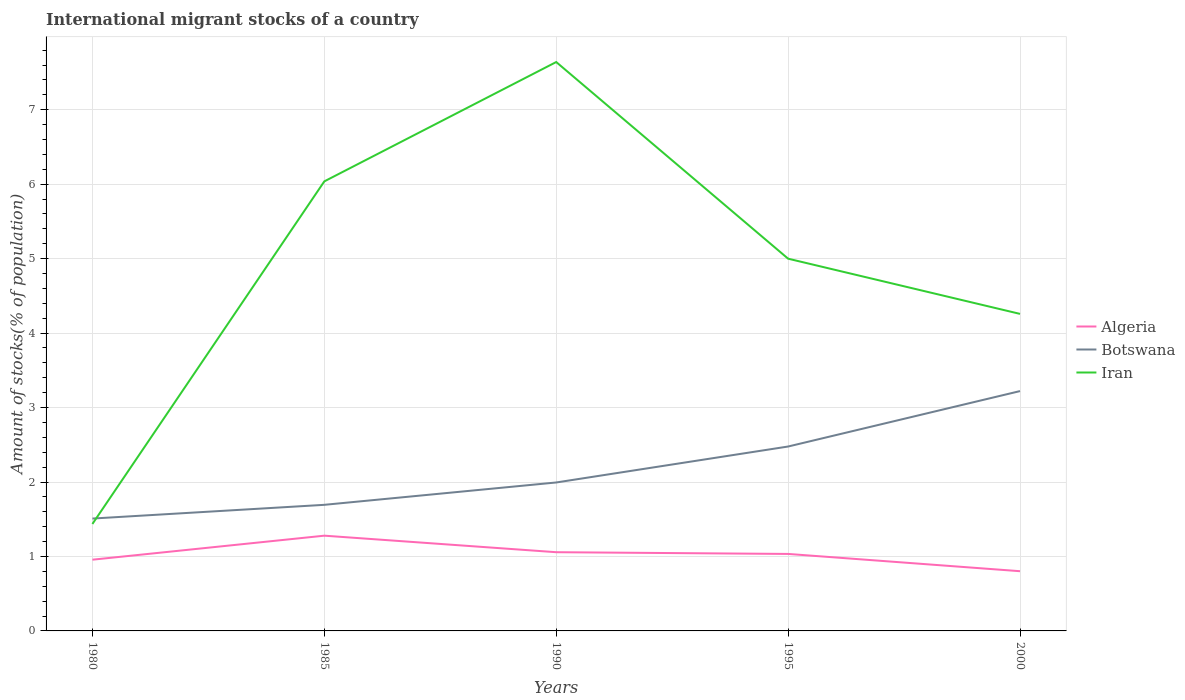How many different coloured lines are there?
Provide a short and direct response. 3. Does the line corresponding to Algeria intersect with the line corresponding to Botswana?
Keep it short and to the point. No. Is the number of lines equal to the number of legend labels?
Provide a succinct answer. Yes. Across all years, what is the maximum amount of stocks in in Iran?
Provide a short and direct response. 1.44. What is the total amount of stocks in in Botswana in the graph?
Your answer should be very brief. -0.97. What is the difference between the highest and the second highest amount of stocks in in Algeria?
Your answer should be very brief. 0.48. What is the difference between the highest and the lowest amount of stocks in in Botswana?
Your response must be concise. 2. Is the amount of stocks in in Iran strictly greater than the amount of stocks in in Botswana over the years?
Your answer should be very brief. No. How many lines are there?
Give a very brief answer. 3. What is the difference between two consecutive major ticks on the Y-axis?
Offer a terse response. 1. Does the graph contain any zero values?
Ensure brevity in your answer.  No. How are the legend labels stacked?
Your answer should be very brief. Vertical. What is the title of the graph?
Your answer should be compact. International migrant stocks of a country. What is the label or title of the X-axis?
Keep it short and to the point. Years. What is the label or title of the Y-axis?
Your answer should be very brief. Amount of stocks(% of population). What is the Amount of stocks(% of population) of Algeria in 1980?
Offer a very short reply. 0.96. What is the Amount of stocks(% of population) of Botswana in 1980?
Give a very brief answer. 1.51. What is the Amount of stocks(% of population) of Iran in 1980?
Offer a terse response. 1.44. What is the Amount of stocks(% of population) of Algeria in 1985?
Provide a succinct answer. 1.28. What is the Amount of stocks(% of population) in Botswana in 1985?
Ensure brevity in your answer.  1.69. What is the Amount of stocks(% of population) in Iran in 1985?
Ensure brevity in your answer.  6.04. What is the Amount of stocks(% of population) of Algeria in 1990?
Offer a very short reply. 1.06. What is the Amount of stocks(% of population) of Botswana in 1990?
Your response must be concise. 1.99. What is the Amount of stocks(% of population) of Iran in 1990?
Your response must be concise. 7.64. What is the Amount of stocks(% of population) of Algeria in 1995?
Keep it short and to the point. 1.03. What is the Amount of stocks(% of population) in Botswana in 1995?
Keep it short and to the point. 2.48. What is the Amount of stocks(% of population) in Iran in 1995?
Offer a very short reply. 5. What is the Amount of stocks(% of population) of Algeria in 2000?
Your answer should be very brief. 0.8. What is the Amount of stocks(% of population) in Botswana in 2000?
Give a very brief answer. 3.22. What is the Amount of stocks(% of population) in Iran in 2000?
Ensure brevity in your answer.  4.26. Across all years, what is the maximum Amount of stocks(% of population) in Algeria?
Your answer should be very brief. 1.28. Across all years, what is the maximum Amount of stocks(% of population) in Botswana?
Your answer should be compact. 3.22. Across all years, what is the maximum Amount of stocks(% of population) in Iran?
Keep it short and to the point. 7.64. Across all years, what is the minimum Amount of stocks(% of population) of Algeria?
Make the answer very short. 0.8. Across all years, what is the minimum Amount of stocks(% of population) of Botswana?
Provide a short and direct response. 1.51. Across all years, what is the minimum Amount of stocks(% of population) in Iran?
Provide a succinct answer. 1.44. What is the total Amount of stocks(% of population) of Algeria in the graph?
Offer a terse response. 5.13. What is the total Amount of stocks(% of population) of Botswana in the graph?
Your answer should be compact. 10.89. What is the total Amount of stocks(% of population) of Iran in the graph?
Keep it short and to the point. 24.37. What is the difference between the Amount of stocks(% of population) in Algeria in 1980 and that in 1985?
Give a very brief answer. -0.32. What is the difference between the Amount of stocks(% of population) of Botswana in 1980 and that in 1985?
Your answer should be compact. -0.18. What is the difference between the Amount of stocks(% of population) in Iran in 1980 and that in 1985?
Offer a very short reply. -4.6. What is the difference between the Amount of stocks(% of population) of Algeria in 1980 and that in 1990?
Keep it short and to the point. -0.1. What is the difference between the Amount of stocks(% of population) in Botswana in 1980 and that in 1990?
Keep it short and to the point. -0.48. What is the difference between the Amount of stocks(% of population) in Iran in 1980 and that in 1990?
Offer a very short reply. -6.2. What is the difference between the Amount of stocks(% of population) in Algeria in 1980 and that in 1995?
Offer a very short reply. -0.08. What is the difference between the Amount of stocks(% of population) of Botswana in 1980 and that in 1995?
Provide a short and direct response. -0.97. What is the difference between the Amount of stocks(% of population) of Iran in 1980 and that in 1995?
Make the answer very short. -3.56. What is the difference between the Amount of stocks(% of population) of Algeria in 1980 and that in 2000?
Your answer should be very brief. 0.15. What is the difference between the Amount of stocks(% of population) of Botswana in 1980 and that in 2000?
Provide a short and direct response. -1.71. What is the difference between the Amount of stocks(% of population) in Iran in 1980 and that in 2000?
Make the answer very short. -2.82. What is the difference between the Amount of stocks(% of population) in Algeria in 1985 and that in 1990?
Provide a succinct answer. 0.22. What is the difference between the Amount of stocks(% of population) of Botswana in 1985 and that in 1990?
Keep it short and to the point. -0.3. What is the difference between the Amount of stocks(% of population) of Iran in 1985 and that in 1990?
Ensure brevity in your answer.  -1.6. What is the difference between the Amount of stocks(% of population) in Algeria in 1985 and that in 1995?
Provide a short and direct response. 0.25. What is the difference between the Amount of stocks(% of population) of Botswana in 1985 and that in 1995?
Your answer should be very brief. -0.78. What is the difference between the Amount of stocks(% of population) of Iran in 1985 and that in 1995?
Provide a succinct answer. 1.04. What is the difference between the Amount of stocks(% of population) of Algeria in 1985 and that in 2000?
Offer a very short reply. 0.48. What is the difference between the Amount of stocks(% of population) in Botswana in 1985 and that in 2000?
Offer a very short reply. -1.53. What is the difference between the Amount of stocks(% of population) of Iran in 1985 and that in 2000?
Offer a very short reply. 1.78. What is the difference between the Amount of stocks(% of population) of Algeria in 1990 and that in 1995?
Your response must be concise. 0.02. What is the difference between the Amount of stocks(% of population) in Botswana in 1990 and that in 1995?
Offer a terse response. -0.48. What is the difference between the Amount of stocks(% of population) of Iran in 1990 and that in 1995?
Provide a succinct answer. 2.64. What is the difference between the Amount of stocks(% of population) in Algeria in 1990 and that in 2000?
Give a very brief answer. 0.26. What is the difference between the Amount of stocks(% of population) of Botswana in 1990 and that in 2000?
Ensure brevity in your answer.  -1.23. What is the difference between the Amount of stocks(% of population) of Iran in 1990 and that in 2000?
Your response must be concise. 3.38. What is the difference between the Amount of stocks(% of population) in Algeria in 1995 and that in 2000?
Offer a very short reply. 0.23. What is the difference between the Amount of stocks(% of population) of Botswana in 1995 and that in 2000?
Ensure brevity in your answer.  -0.74. What is the difference between the Amount of stocks(% of population) of Iran in 1995 and that in 2000?
Provide a succinct answer. 0.74. What is the difference between the Amount of stocks(% of population) of Algeria in 1980 and the Amount of stocks(% of population) of Botswana in 1985?
Make the answer very short. -0.74. What is the difference between the Amount of stocks(% of population) of Algeria in 1980 and the Amount of stocks(% of population) of Iran in 1985?
Make the answer very short. -5.08. What is the difference between the Amount of stocks(% of population) in Botswana in 1980 and the Amount of stocks(% of population) in Iran in 1985?
Make the answer very short. -4.53. What is the difference between the Amount of stocks(% of population) in Algeria in 1980 and the Amount of stocks(% of population) in Botswana in 1990?
Give a very brief answer. -1.04. What is the difference between the Amount of stocks(% of population) of Algeria in 1980 and the Amount of stocks(% of population) of Iran in 1990?
Your answer should be compact. -6.68. What is the difference between the Amount of stocks(% of population) in Botswana in 1980 and the Amount of stocks(% of population) in Iran in 1990?
Your answer should be very brief. -6.13. What is the difference between the Amount of stocks(% of population) of Algeria in 1980 and the Amount of stocks(% of population) of Botswana in 1995?
Your response must be concise. -1.52. What is the difference between the Amount of stocks(% of population) in Algeria in 1980 and the Amount of stocks(% of population) in Iran in 1995?
Keep it short and to the point. -4.04. What is the difference between the Amount of stocks(% of population) in Botswana in 1980 and the Amount of stocks(% of population) in Iran in 1995?
Keep it short and to the point. -3.49. What is the difference between the Amount of stocks(% of population) in Algeria in 1980 and the Amount of stocks(% of population) in Botswana in 2000?
Offer a very short reply. -2.26. What is the difference between the Amount of stocks(% of population) in Algeria in 1980 and the Amount of stocks(% of population) in Iran in 2000?
Your answer should be very brief. -3.3. What is the difference between the Amount of stocks(% of population) in Botswana in 1980 and the Amount of stocks(% of population) in Iran in 2000?
Your answer should be compact. -2.75. What is the difference between the Amount of stocks(% of population) of Algeria in 1985 and the Amount of stocks(% of population) of Botswana in 1990?
Make the answer very short. -0.71. What is the difference between the Amount of stocks(% of population) of Algeria in 1985 and the Amount of stocks(% of population) of Iran in 1990?
Keep it short and to the point. -6.36. What is the difference between the Amount of stocks(% of population) of Botswana in 1985 and the Amount of stocks(% of population) of Iran in 1990?
Give a very brief answer. -5.95. What is the difference between the Amount of stocks(% of population) of Algeria in 1985 and the Amount of stocks(% of population) of Botswana in 1995?
Make the answer very short. -1.2. What is the difference between the Amount of stocks(% of population) of Algeria in 1985 and the Amount of stocks(% of population) of Iran in 1995?
Your answer should be compact. -3.72. What is the difference between the Amount of stocks(% of population) of Botswana in 1985 and the Amount of stocks(% of population) of Iran in 1995?
Make the answer very short. -3.31. What is the difference between the Amount of stocks(% of population) of Algeria in 1985 and the Amount of stocks(% of population) of Botswana in 2000?
Provide a short and direct response. -1.94. What is the difference between the Amount of stocks(% of population) in Algeria in 1985 and the Amount of stocks(% of population) in Iran in 2000?
Keep it short and to the point. -2.98. What is the difference between the Amount of stocks(% of population) in Botswana in 1985 and the Amount of stocks(% of population) in Iran in 2000?
Your answer should be compact. -2.56. What is the difference between the Amount of stocks(% of population) of Algeria in 1990 and the Amount of stocks(% of population) of Botswana in 1995?
Ensure brevity in your answer.  -1.42. What is the difference between the Amount of stocks(% of population) of Algeria in 1990 and the Amount of stocks(% of population) of Iran in 1995?
Give a very brief answer. -3.94. What is the difference between the Amount of stocks(% of population) in Botswana in 1990 and the Amount of stocks(% of population) in Iran in 1995?
Your answer should be compact. -3.01. What is the difference between the Amount of stocks(% of population) of Algeria in 1990 and the Amount of stocks(% of population) of Botswana in 2000?
Provide a short and direct response. -2.16. What is the difference between the Amount of stocks(% of population) in Algeria in 1990 and the Amount of stocks(% of population) in Iran in 2000?
Give a very brief answer. -3.2. What is the difference between the Amount of stocks(% of population) in Botswana in 1990 and the Amount of stocks(% of population) in Iran in 2000?
Provide a succinct answer. -2.26. What is the difference between the Amount of stocks(% of population) of Algeria in 1995 and the Amount of stocks(% of population) of Botswana in 2000?
Ensure brevity in your answer.  -2.19. What is the difference between the Amount of stocks(% of population) in Algeria in 1995 and the Amount of stocks(% of population) in Iran in 2000?
Keep it short and to the point. -3.22. What is the difference between the Amount of stocks(% of population) in Botswana in 1995 and the Amount of stocks(% of population) in Iran in 2000?
Provide a succinct answer. -1.78. What is the average Amount of stocks(% of population) of Algeria per year?
Ensure brevity in your answer.  1.03. What is the average Amount of stocks(% of population) in Botswana per year?
Keep it short and to the point. 2.18. What is the average Amount of stocks(% of population) of Iran per year?
Your answer should be very brief. 4.87. In the year 1980, what is the difference between the Amount of stocks(% of population) in Algeria and Amount of stocks(% of population) in Botswana?
Ensure brevity in your answer.  -0.55. In the year 1980, what is the difference between the Amount of stocks(% of population) of Algeria and Amount of stocks(% of population) of Iran?
Provide a succinct answer. -0.48. In the year 1980, what is the difference between the Amount of stocks(% of population) in Botswana and Amount of stocks(% of population) in Iran?
Ensure brevity in your answer.  0.07. In the year 1985, what is the difference between the Amount of stocks(% of population) of Algeria and Amount of stocks(% of population) of Botswana?
Your answer should be compact. -0.41. In the year 1985, what is the difference between the Amount of stocks(% of population) in Algeria and Amount of stocks(% of population) in Iran?
Your answer should be compact. -4.76. In the year 1985, what is the difference between the Amount of stocks(% of population) in Botswana and Amount of stocks(% of population) in Iran?
Provide a short and direct response. -4.34. In the year 1990, what is the difference between the Amount of stocks(% of population) in Algeria and Amount of stocks(% of population) in Botswana?
Provide a short and direct response. -0.94. In the year 1990, what is the difference between the Amount of stocks(% of population) of Algeria and Amount of stocks(% of population) of Iran?
Make the answer very short. -6.58. In the year 1990, what is the difference between the Amount of stocks(% of population) of Botswana and Amount of stocks(% of population) of Iran?
Ensure brevity in your answer.  -5.65. In the year 1995, what is the difference between the Amount of stocks(% of population) of Algeria and Amount of stocks(% of population) of Botswana?
Provide a succinct answer. -1.44. In the year 1995, what is the difference between the Amount of stocks(% of population) of Algeria and Amount of stocks(% of population) of Iran?
Your response must be concise. -3.97. In the year 1995, what is the difference between the Amount of stocks(% of population) in Botswana and Amount of stocks(% of population) in Iran?
Provide a short and direct response. -2.52. In the year 2000, what is the difference between the Amount of stocks(% of population) in Algeria and Amount of stocks(% of population) in Botswana?
Your answer should be compact. -2.42. In the year 2000, what is the difference between the Amount of stocks(% of population) in Algeria and Amount of stocks(% of population) in Iran?
Make the answer very short. -3.46. In the year 2000, what is the difference between the Amount of stocks(% of population) of Botswana and Amount of stocks(% of population) of Iran?
Provide a short and direct response. -1.04. What is the ratio of the Amount of stocks(% of population) in Algeria in 1980 to that in 1985?
Keep it short and to the point. 0.75. What is the ratio of the Amount of stocks(% of population) of Botswana in 1980 to that in 1985?
Your answer should be compact. 0.89. What is the ratio of the Amount of stocks(% of population) of Iran in 1980 to that in 1985?
Provide a short and direct response. 0.24. What is the ratio of the Amount of stocks(% of population) in Algeria in 1980 to that in 1990?
Ensure brevity in your answer.  0.9. What is the ratio of the Amount of stocks(% of population) of Botswana in 1980 to that in 1990?
Ensure brevity in your answer.  0.76. What is the ratio of the Amount of stocks(% of population) of Iran in 1980 to that in 1990?
Your answer should be very brief. 0.19. What is the ratio of the Amount of stocks(% of population) of Algeria in 1980 to that in 1995?
Ensure brevity in your answer.  0.93. What is the ratio of the Amount of stocks(% of population) of Botswana in 1980 to that in 1995?
Your answer should be very brief. 0.61. What is the ratio of the Amount of stocks(% of population) in Iran in 1980 to that in 1995?
Offer a terse response. 0.29. What is the ratio of the Amount of stocks(% of population) in Algeria in 1980 to that in 2000?
Make the answer very short. 1.19. What is the ratio of the Amount of stocks(% of population) of Botswana in 1980 to that in 2000?
Ensure brevity in your answer.  0.47. What is the ratio of the Amount of stocks(% of population) of Iran in 1980 to that in 2000?
Ensure brevity in your answer.  0.34. What is the ratio of the Amount of stocks(% of population) of Algeria in 1985 to that in 1990?
Offer a very short reply. 1.21. What is the ratio of the Amount of stocks(% of population) in Botswana in 1985 to that in 1990?
Keep it short and to the point. 0.85. What is the ratio of the Amount of stocks(% of population) in Iran in 1985 to that in 1990?
Your answer should be very brief. 0.79. What is the ratio of the Amount of stocks(% of population) in Algeria in 1985 to that in 1995?
Your answer should be compact. 1.24. What is the ratio of the Amount of stocks(% of population) of Botswana in 1985 to that in 1995?
Provide a short and direct response. 0.68. What is the ratio of the Amount of stocks(% of population) in Iran in 1985 to that in 1995?
Your response must be concise. 1.21. What is the ratio of the Amount of stocks(% of population) of Algeria in 1985 to that in 2000?
Your answer should be very brief. 1.59. What is the ratio of the Amount of stocks(% of population) in Botswana in 1985 to that in 2000?
Provide a succinct answer. 0.53. What is the ratio of the Amount of stocks(% of population) in Iran in 1985 to that in 2000?
Give a very brief answer. 1.42. What is the ratio of the Amount of stocks(% of population) in Algeria in 1990 to that in 1995?
Make the answer very short. 1.02. What is the ratio of the Amount of stocks(% of population) in Botswana in 1990 to that in 1995?
Offer a very short reply. 0.81. What is the ratio of the Amount of stocks(% of population) of Iran in 1990 to that in 1995?
Your answer should be compact. 1.53. What is the ratio of the Amount of stocks(% of population) of Algeria in 1990 to that in 2000?
Your answer should be very brief. 1.32. What is the ratio of the Amount of stocks(% of population) of Botswana in 1990 to that in 2000?
Offer a very short reply. 0.62. What is the ratio of the Amount of stocks(% of population) of Iran in 1990 to that in 2000?
Keep it short and to the point. 1.79. What is the ratio of the Amount of stocks(% of population) of Algeria in 1995 to that in 2000?
Make the answer very short. 1.29. What is the ratio of the Amount of stocks(% of population) in Botswana in 1995 to that in 2000?
Provide a succinct answer. 0.77. What is the ratio of the Amount of stocks(% of population) of Iran in 1995 to that in 2000?
Your answer should be very brief. 1.17. What is the difference between the highest and the second highest Amount of stocks(% of population) of Algeria?
Offer a very short reply. 0.22. What is the difference between the highest and the second highest Amount of stocks(% of population) in Botswana?
Ensure brevity in your answer.  0.74. What is the difference between the highest and the second highest Amount of stocks(% of population) in Iran?
Make the answer very short. 1.6. What is the difference between the highest and the lowest Amount of stocks(% of population) in Algeria?
Make the answer very short. 0.48. What is the difference between the highest and the lowest Amount of stocks(% of population) in Botswana?
Provide a short and direct response. 1.71. What is the difference between the highest and the lowest Amount of stocks(% of population) of Iran?
Your answer should be compact. 6.2. 